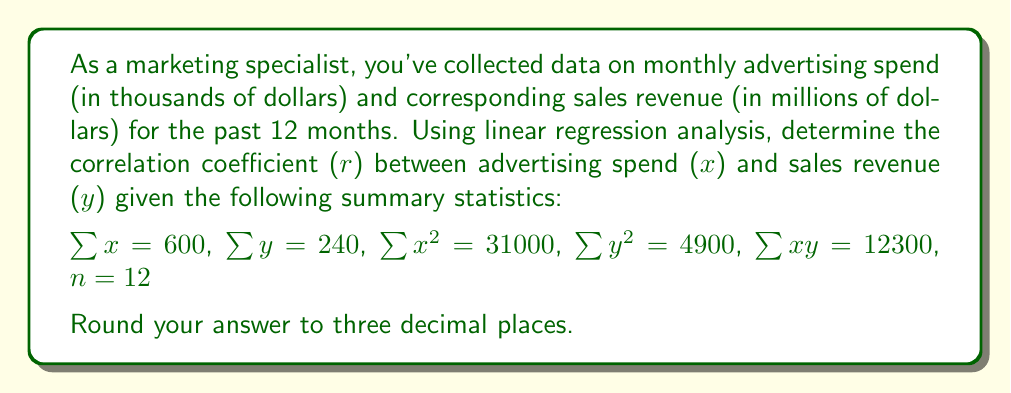Solve this math problem. To calculate the correlation coefficient (r), we'll use the formula:

$$r = \frac{n\sum xy - \sum x \sum y}{\sqrt{[n\sum x^2 - (\sum x)^2][n\sum y^2 - (\sum y)^2]}}$$

Let's substitute the given values:

1) $n = 12$
2) $\sum x = 600$
3) $\sum y = 240$
4) $\sum x^2 = 31000$
5) $\sum y^2 = 4900$
6) $\sum xy = 12300$

Now, let's calculate step by step:

Step 1: Calculate $n\sum xy$
$12 * 12300 = 147600$

Step 2: Calculate $\sum x \sum y$
$600 * 240 = 144000$

Step 3: Calculate numerator
$147600 - 144000 = 3600$

Step 4: Calculate $n\sum x^2$
$12 * 31000 = 372000$

Step 5: Calculate $(\sum x)^2$
$600^2 = 360000$

Step 6: Calculate $n\sum y^2$
$12 * 4900 = 58800$

Step 7: Calculate $(\sum y)^2$
$240^2 = 57600$

Step 8: Calculate denominator
$\sqrt{(372000 - 360000)(58800 - 57600)} = \sqrt{(12000)(1200)} = \sqrt{14400000} = 3794.73$

Step 9: Divide numerator by denominator
$r = 3600 / 3794.73 = 0.9487$

Step 10: Round to three decimal places
$r = 0.949$
Answer: 0.949 